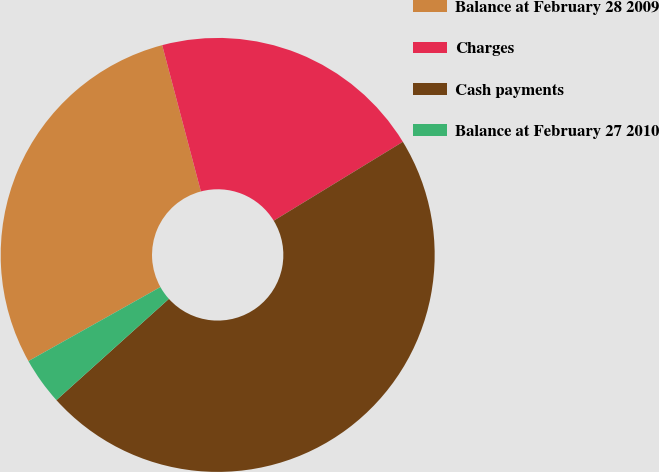Convert chart. <chart><loc_0><loc_0><loc_500><loc_500><pie_chart><fcel>Balance at February 28 2009<fcel>Charges<fcel>Cash payments<fcel>Balance at February 27 2010<nl><fcel>29.02%<fcel>20.39%<fcel>47.06%<fcel>3.53%<nl></chart> 